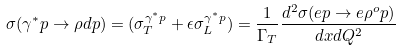Convert formula to latex. <formula><loc_0><loc_0><loc_500><loc_500>\sigma ( \gamma ^ { * } p \rightarrow \rho d p ) = ( \sigma _ { T } ^ { \gamma ^ { * } p } + \epsilon \sigma _ { L } ^ { \gamma ^ { * } p } ) = \frac { 1 } { \Gamma _ { T } } \frac { d ^ { 2 } \sigma ( e p \rightarrow e \rho ^ { o } p ) } { d x d Q ^ { 2 } }</formula> 